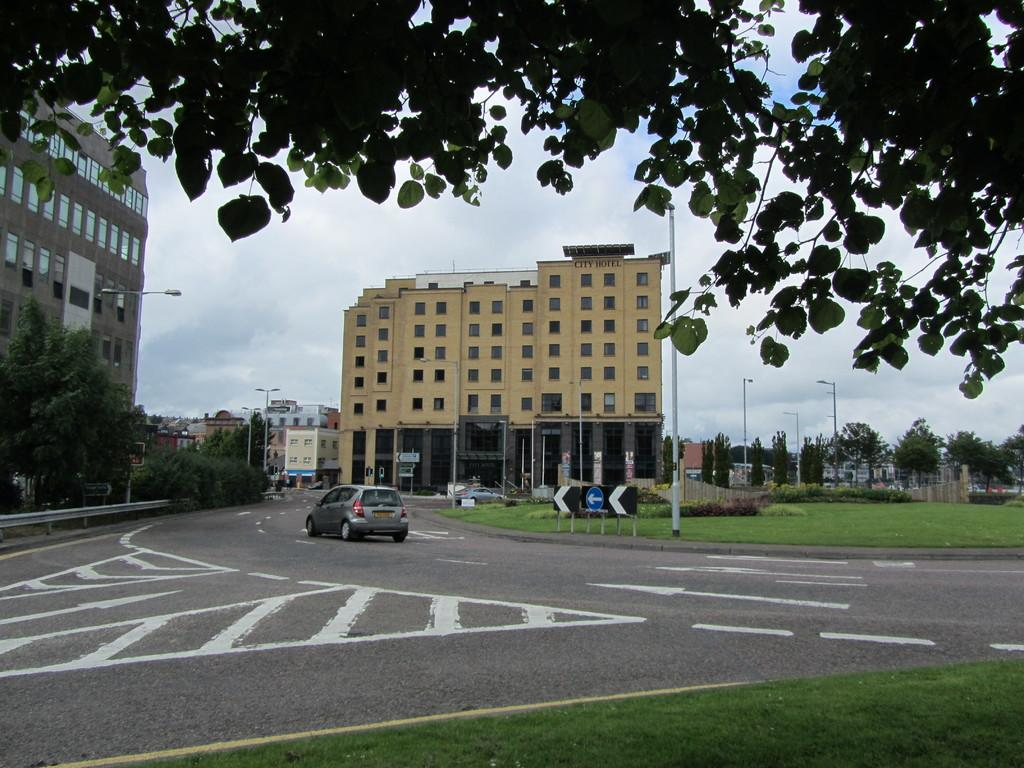What type of structures are visible in the image? There are buildings in the image. What type of lighting is present in the image? There are street lamps in the image. What type of vegetation is visible in the image? There are trees in the image. What type of signage is present in the image? There is a banner in the image. What type of ground cover is visible in the image? There is grass in the image. What type of vehicle is visible in the image? There is a car in the image. What is visible at the top of the image? The sky is visible at the top of the image. What type of pie is being served on the quilt in the image? There is no pie or quilt present in the image. What type of silk is draped over the car in the image? There is no silk present in the image. 